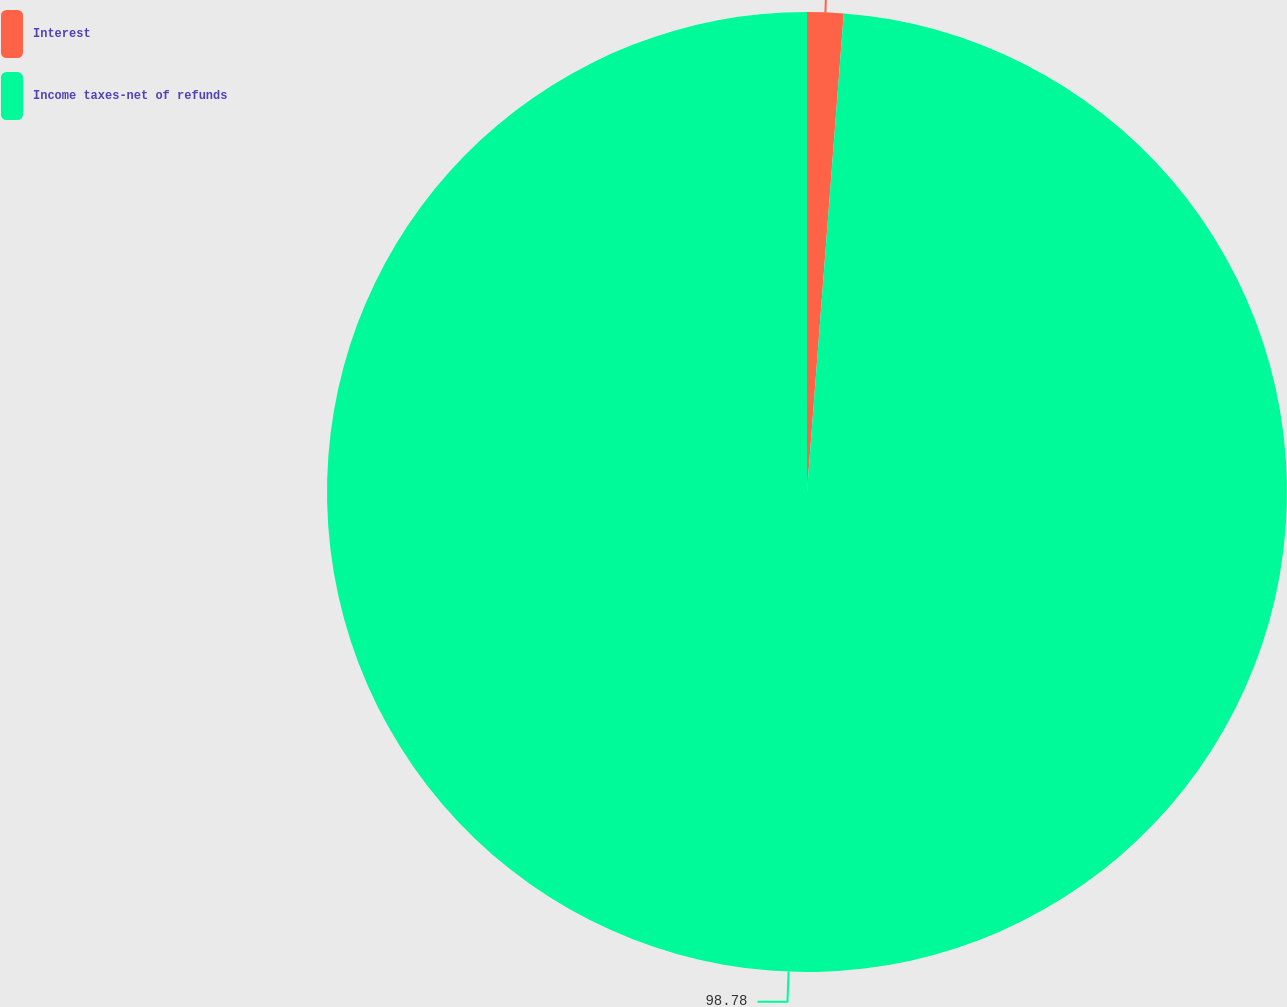Convert chart. <chart><loc_0><loc_0><loc_500><loc_500><pie_chart><fcel>Interest<fcel>Income taxes-net of refunds<nl><fcel>1.22%<fcel>98.78%<nl></chart> 